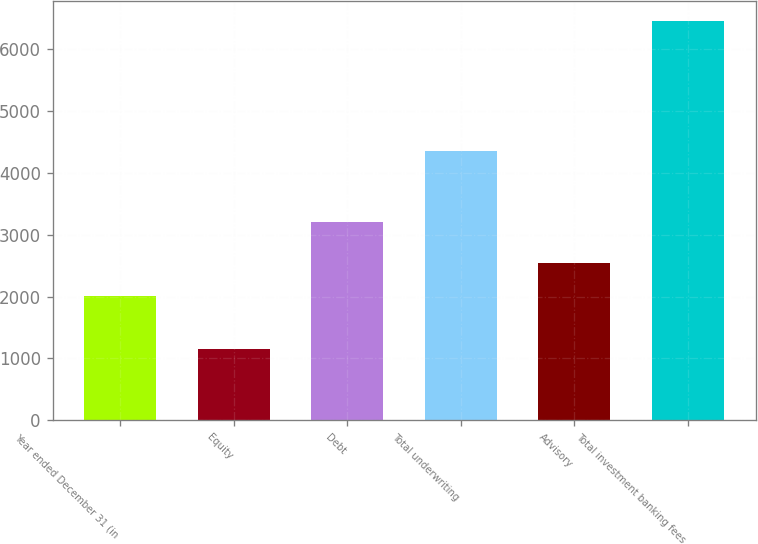<chart> <loc_0><loc_0><loc_500><loc_500><bar_chart><fcel>Year ended December 31 (in<fcel>Equity<fcel>Debt<fcel>Total underwriting<fcel>Advisory<fcel>Total investment banking fees<nl><fcel>2016<fcel>1146<fcel>3207<fcel>4353<fcel>2546.2<fcel>6448<nl></chart> 